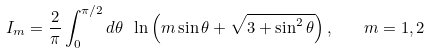Convert formula to latex. <formula><loc_0><loc_0><loc_500><loc_500>I _ { m } = \frac { 2 } { \pi } \int _ { 0 } ^ { \pi / 2 } d \theta \ \ln \left ( m \sin \theta + \sqrt { 3 + \sin ^ { 2 } \theta } \right ) , \quad m = 1 , 2</formula> 